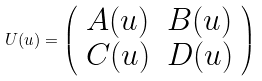<formula> <loc_0><loc_0><loc_500><loc_500>U ( u ) = \left ( \begin{array} { l l } { A ( u ) } & { B ( u ) } \\ { C ( u ) } & { D ( u ) } \end{array} \right )</formula> 